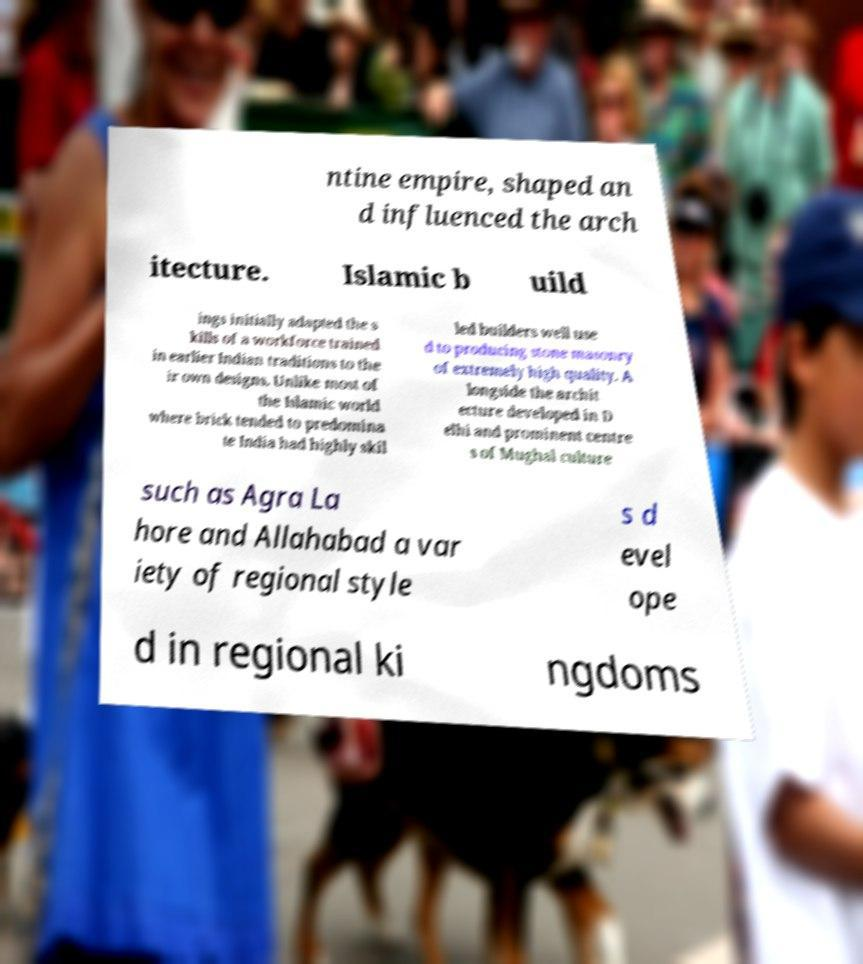Please identify and transcribe the text found in this image. ntine empire, shaped an d influenced the arch itecture. Islamic b uild ings initially adapted the s kills of a workforce trained in earlier Indian traditions to the ir own designs. Unlike most of the Islamic world where brick tended to predomina te India had highly skil led builders well use d to producing stone masonry of extremely high quality. A longside the archit ecture developed in D elhi and prominent centre s of Mughal culture such as Agra La hore and Allahabad a var iety of regional style s d evel ope d in regional ki ngdoms 